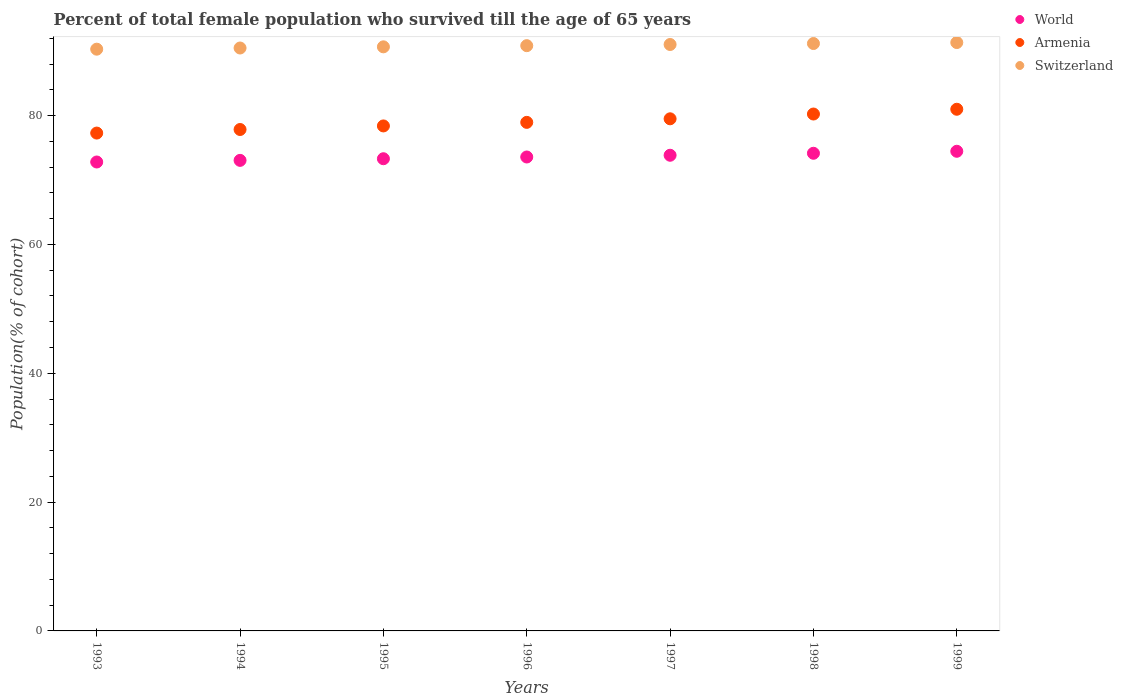How many different coloured dotlines are there?
Offer a very short reply. 3. What is the percentage of total female population who survived till the age of 65 years in World in 1997?
Ensure brevity in your answer.  73.84. Across all years, what is the maximum percentage of total female population who survived till the age of 65 years in Armenia?
Provide a short and direct response. 80.99. Across all years, what is the minimum percentage of total female population who survived till the age of 65 years in World?
Offer a very short reply. 72.8. In which year was the percentage of total female population who survived till the age of 65 years in Switzerland maximum?
Provide a succinct answer. 1999. What is the total percentage of total female population who survived till the age of 65 years in World in the graph?
Keep it short and to the point. 515.19. What is the difference between the percentage of total female population who survived till the age of 65 years in Switzerland in 1993 and that in 1996?
Keep it short and to the point. -0.54. What is the difference between the percentage of total female population who survived till the age of 65 years in Switzerland in 1997 and the percentage of total female population who survived till the age of 65 years in Armenia in 1996?
Provide a succinct answer. 12.09. What is the average percentage of total female population who survived till the age of 65 years in Armenia per year?
Give a very brief answer. 79.03. In the year 1994, what is the difference between the percentage of total female population who survived till the age of 65 years in Armenia and percentage of total female population who survived till the age of 65 years in World?
Your answer should be very brief. 4.79. What is the ratio of the percentage of total female population who survived till the age of 65 years in World in 1993 to that in 1994?
Provide a succinct answer. 1. Is the difference between the percentage of total female population who survived till the age of 65 years in Armenia in 1998 and 1999 greater than the difference between the percentage of total female population who survived till the age of 65 years in World in 1998 and 1999?
Offer a terse response. No. What is the difference between the highest and the second highest percentage of total female population who survived till the age of 65 years in World?
Your answer should be very brief. 0.31. What is the difference between the highest and the lowest percentage of total female population who survived till the age of 65 years in Armenia?
Your answer should be very brief. 3.7. In how many years, is the percentage of total female population who survived till the age of 65 years in Switzerland greater than the average percentage of total female population who survived till the age of 65 years in Switzerland taken over all years?
Provide a succinct answer. 4. Is it the case that in every year, the sum of the percentage of total female population who survived till the age of 65 years in World and percentage of total female population who survived till the age of 65 years in Armenia  is greater than the percentage of total female population who survived till the age of 65 years in Switzerland?
Make the answer very short. Yes. Is the percentage of total female population who survived till the age of 65 years in Switzerland strictly less than the percentage of total female population who survived till the age of 65 years in Armenia over the years?
Offer a very short reply. No. Does the graph contain any zero values?
Your response must be concise. No. Does the graph contain grids?
Make the answer very short. No. How are the legend labels stacked?
Provide a succinct answer. Vertical. What is the title of the graph?
Offer a very short reply. Percent of total female population who survived till the age of 65 years. What is the label or title of the Y-axis?
Offer a terse response. Population(% of cohort). What is the Population(% of cohort) of World in 1993?
Offer a terse response. 72.8. What is the Population(% of cohort) in Armenia in 1993?
Provide a succinct answer. 77.29. What is the Population(% of cohort) in Switzerland in 1993?
Provide a short and direct response. 90.31. What is the Population(% of cohort) in World in 1994?
Give a very brief answer. 73.05. What is the Population(% of cohort) in Armenia in 1994?
Provide a succinct answer. 77.84. What is the Population(% of cohort) in Switzerland in 1994?
Your answer should be compact. 90.49. What is the Population(% of cohort) in World in 1995?
Offer a terse response. 73.3. What is the Population(% of cohort) in Armenia in 1995?
Provide a succinct answer. 78.4. What is the Population(% of cohort) in Switzerland in 1995?
Offer a very short reply. 90.68. What is the Population(% of cohort) in World in 1996?
Give a very brief answer. 73.58. What is the Population(% of cohort) in Armenia in 1996?
Make the answer very short. 78.95. What is the Population(% of cohort) of Switzerland in 1996?
Ensure brevity in your answer.  90.86. What is the Population(% of cohort) of World in 1997?
Offer a terse response. 73.84. What is the Population(% of cohort) of Armenia in 1997?
Provide a succinct answer. 79.5. What is the Population(% of cohort) in Switzerland in 1997?
Your answer should be compact. 91.04. What is the Population(% of cohort) in World in 1998?
Give a very brief answer. 74.15. What is the Population(% of cohort) of Armenia in 1998?
Provide a succinct answer. 80.25. What is the Population(% of cohort) of Switzerland in 1998?
Ensure brevity in your answer.  91.19. What is the Population(% of cohort) in World in 1999?
Ensure brevity in your answer.  74.46. What is the Population(% of cohort) in Armenia in 1999?
Provide a succinct answer. 80.99. What is the Population(% of cohort) in Switzerland in 1999?
Keep it short and to the point. 91.34. Across all years, what is the maximum Population(% of cohort) in World?
Provide a short and direct response. 74.46. Across all years, what is the maximum Population(% of cohort) in Armenia?
Provide a succinct answer. 80.99. Across all years, what is the maximum Population(% of cohort) of Switzerland?
Your response must be concise. 91.34. Across all years, what is the minimum Population(% of cohort) of World?
Ensure brevity in your answer.  72.8. Across all years, what is the minimum Population(% of cohort) in Armenia?
Offer a terse response. 77.29. Across all years, what is the minimum Population(% of cohort) in Switzerland?
Ensure brevity in your answer.  90.31. What is the total Population(% of cohort) of World in the graph?
Your answer should be compact. 515.19. What is the total Population(% of cohort) in Armenia in the graph?
Offer a terse response. 553.21. What is the total Population(% of cohort) of Switzerland in the graph?
Give a very brief answer. 635.91. What is the difference between the Population(% of cohort) in World in 1993 and that in 1994?
Your response must be concise. -0.25. What is the difference between the Population(% of cohort) of Armenia in 1993 and that in 1994?
Your answer should be compact. -0.55. What is the difference between the Population(% of cohort) in Switzerland in 1993 and that in 1994?
Your answer should be very brief. -0.18. What is the difference between the Population(% of cohort) of World in 1993 and that in 1995?
Keep it short and to the point. -0.51. What is the difference between the Population(% of cohort) of Armenia in 1993 and that in 1995?
Provide a succinct answer. -1.11. What is the difference between the Population(% of cohort) of Switzerland in 1993 and that in 1995?
Give a very brief answer. -0.36. What is the difference between the Population(% of cohort) of World in 1993 and that in 1996?
Your response must be concise. -0.78. What is the difference between the Population(% of cohort) in Armenia in 1993 and that in 1996?
Provide a short and direct response. -1.66. What is the difference between the Population(% of cohort) in Switzerland in 1993 and that in 1996?
Provide a succinct answer. -0.54. What is the difference between the Population(% of cohort) in World in 1993 and that in 1997?
Your response must be concise. -1.05. What is the difference between the Population(% of cohort) in Armenia in 1993 and that in 1997?
Offer a very short reply. -2.22. What is the difference between the Population(% of cohort) of Switzerland in 1993 and that in 1997?
Make the answer very short. -0.73. What is the difference between the Population(% of cohort) of World in 1993 and that in 1998?
Ensure brevity in your answer.  -1.35. What is the difference between the Population(% of cohort) of Armenia in 1993 and that in 1998?
Offer a very short reply. -2.96. What is the difference between the Population(% of cohort) in Switzerland in 1993 and that in 1998?
Your answer should be compact. -0.88. What is the difference between the Population(% of cohort) in World in 1993 and that in 1999?
Provide a short and direct response. -1.66. What is the difference between the Population(% of cohort) in Armenia in 1993 and that in 1999?
Provide a short and direct response. -3.7. What is the difference between the Population(% of cohort) of Switzerland in 1993 and that in 1999?
Give a very brief answer. -1.03. What is the difference between the Population(% of cohort) in World in 1994 and that in 1995?
Provide a short and direct response. -0.25. What is the difference between the Population(% of cohort) in Armenia in 1994 and that in 1995?
Your answer should be very brief. -0.55. What is the difference between the Population(% of cohort) of Switzerland in 1994 and that in 1995?
Provide a succinct answer. -0.18. What is the difference between the Population(% of cohort) of World in 1994 and that in 1996?
Give a very brief answer. -0.53. What is the difference between the Population(% of cohort) of Armenia in 1994 and that in 1996?
Make the answer very short. -1.11. What is the difference between the Population(% of cohort) of Switzerland in 1994 and that in 1996?
Your response must be concise. -0.36. What is the difference between the Population(% of cohort) of World in 1994 and that in 1997?
Keep it short and to the point. -0.79. What is the difference between the Population(% of cohort) of Armenia in 1994 and that in 1997?
Give a very brief answer. -1.66. What is the difference between the Population(% of cohort) of Switzerland in 1994 and that in 1997?
Provide a short and direct response. -0.54. What is the difference between the Population(% of cohort) of World in 1994 and that in 1998?
Your answer should be compact. -1.1. What is the difference between the Population(% of cohort) in Armenia in 1994 and that in 1998?
Your answer should be compact. -2.4. What is the difference between the Population(% of cohort) of Switzerland in 1994 and that in 1998?
Your answer should be very brief. -0.7. What is the difference between the Population(% of cohort) of World in 1994 and that in 1999?
Ensure brevity in your answer.  -1.41. What is the difference between the Population(% of cohort) of Armenia in 1994 and that in 1999?
Keep it short and to the point. -3.14. What is the difference between the Population(% of cohort) of Switzerland in 1994 and that in 1999?
Your answer should be very brief. -0.85. What is the difference between the Population(% of cohort) of World in 1995 and that in 1996?
Ensure brevity in your answer.  -0.27. What is the difference between the Population(% of cohort) of Armenia in 1995 and that in 1996?
Give a very brief answer. -0.55. What is the difference between the Population(% of cohort) in Switzerland in 1995 and that in 1996?
Your response must be concise. -0.18. What is the difference between the Population(% of cohort) of World in 1995 and that in 1997?
Your response must be concise. -0.54. What is the difference between the Population(% of cohort) of Armenia in 1995 and that in 1997?
Your answer should be compact. -1.11. What is the difference between the Population(% of cohort) in Switzerland in 1995 and that in 1997?
Your answer should be compact. -0.36. What is the difference between the Population(% of cohort) in World in 1995 and that in 1998?
Your answer should be compact. -0.85. What is the difference between the Population(% of cohort) of Armenia in 1995 and that in 1998?
Provide a short and direct response. -1.85. What is the difference between the Population(% of cohort) in Switzerland in 1995 and that in 1998?
Make the answer very short. -0.51. What is the difference between the Population(% of cohort) of World in 1995 and that in 1999?
Keep it short and to the point. -1.16. What is the difference between the Population(% of cohort) in Armenia in 1995 and that in 1999?
Provide a succinct answer. -2.59. What is the difference between the Population(% of cohort) in Switzerland in 1995 and that in 1999?
Give a very brief answer. -0.67. What is the difference between the Population(% of cohort) in World in 1996 and that in 1997?
Give a very brief answer. -0.27. What is the difference between the Population(% of cohort) of Armenia in 1996 and that in 1997?
Provide a succinct answer. -0.55. What is the difference between the Population(% of cohort) in Switzerland in 1996 and that in 1997?
Offer a terse response. -0.18. What is the difference between the Population(% of cohort) in World in 1996 and that in 1998?
Provide a short and direct response. -0.58. What is the difference between the Population(% of cohort) of Armenia in 1996 and that in 1998?
Offer a terse response. -1.29. What is the difference between the Population(% of cohort) of Switzerland in 1996 and that in 1998?
Ensure brevity in your answer.  -0.33. What is the difference between the Population(% of cohort) in World in 1996 and that in 1999?
Ensure brevity in your answer.  -0.89. What is the difference between the Population(% of cohort) in Armenia in 1996 and that in 1999?
Your answer should be compact. -2.04. What is the difference between the Population(% of cohort) in Switzerland in 1996 and that in 1999?
Your answer should be compact. -0.48. What is the difference between the Population(% of cohort) in World in 1997 and that in 1998?
Offer a terse response. -0.31. What is the difference between the Population(% of cohort) in Armenia in 1997 and that in 1998?
Your answer should be compact. -0.74. What is the difference between the Population(% of cohort) of Switzerland in 1997 and that in 1998?
Make the answer very short. -0.15. What is the difference between the Population(% of cohort) of World in 1997 and that in 1999?
Give a very brief answer. -0.62. What is the difference between the Population(% of cohort) in Armenia in 1997 and that in 1999?
Make the answer very short. -1.48. What is the difference between the Population(% of cohort) in Switzerland in 1997 and that in 1999?
Your answer should be compact. -0.3. What is the difference between the Population(% of cohort) in World in 1998 and that in 1999?
Ensure brevity in your answer.  -0.31. What is the difference between the Population(% of cohort) in Armenia in 1998 and that in 1999?
Ensure brevity in your answer.  -0.74. What is the difference between the Population(% of cohort) of Switzerland in 1998 and that in 1999?
Provide a short and direct response. -0.15. What is the difference between the Population(% of cohort) of World in 1993 and the Population(% of cohort) of Armenia in 1994?
Provide a succinct answer. -5.04. What is the difference between the Population(% of cohort) of World in 1993 and the Population(% of cohort) of Switzerland in 1994?
Your answer should be compact. -17.7. What is the difference between the Population(% of cohort) in Armenia in 1993 and the Population(% of cohort) in Switzerland in 1994?
Provide a short and direct response. -13.21. What is the difference between the Population(% of cohort) in World in 1993 and the Population(% of cohort) in Armenia in 1995?
Offer a very short reply. -5.6. What is the difference between the Population(% of cohort) of World in 1993 and the Population(% of cohort) of Switzerland in 1995?
Your answer should be very brief. -17.88. What is the difference between the Population(% of cohort) of Armenia in 1993 and the Population(% of cohort) of Switzerland in 1995?
Keep it short and to the point. -13.39. What is the difference between the Population(% of cohort) of World in 1993 and the Population(% of cohort) of Armenia in 1996?
Make the answer very short. -6.15. What is the difference between the Population(% of cohort) of World in 1993 and the Population(% of cohort) of Switzerland in 1996?
Ensure brevity in your answer.  -18.06. What is the difference between the Population(% of cohort) in Armenia in 1993 and the Population(% of cohort) in Switzerland in 1996?
Offer a terse response. -13.57. What is the difference between the Population(% of cohort) of World in 1993 and the Population(% of cohort) of Armenia in 1997?
Offer a terse response. -6.71. What is the difference between the Population(% of cohort) in World in 1993 and the Population(% of cohort) in Switzerland in 1997?
Your response must be concise. -18.24. What is the difference between the Population(% of cohort) of Armenia in 1993 and the Population(% of cohort) of Switzerland in 1997?
Keep it short and to the point. -13.75. What is the difference between the Population(% of cohort) of World in 1993 and the Population(% of cohort) of Armenia in 1998?
Keep it short and to the point. -7.45. What is the difference between the Population(% of cohort) in World in 1993 and the Population(% of cohort) in Switzerland in 1998?
Make the answer very short. -18.39. What is the difference between the Population(% of cohort) in Armenia in 1993 and the Population(% of cohort) in Switzerland in 1998?
Offer a very short reply. -13.9. What is the difference between the Population(% of cohort) in World in 1993 and the Population(% of cohort) in Armenia in 1999?
Offer a terse response. -8.19. What is the difference between the Population(% of cohort) of World in 1993 and the Population(% of cohort) of Switzerland in 1999?
Keep it short and to the point. -18.54. What is the difference between the Population(% of cohort) in Armenia in 1993 and the Population(% of cohort) in Switzerland in 1999?
Offer a terse response. -14.05. What is the difference between the Population(% of cohort) in World in 1994 and the Population(% of cohort) in Armenia in 1995?
Your answer should be compact. -5.35. What is the difference between the Population(% of cohort) of World in 1994 and the Population(% of cohort) of Switzerland in 1995?
Ensure brevity in your answer.  -17.63. What is the difference between the Population(% of cohort) in Armenia in 1994 and the Population(% of cohort) in Switzerland in 1995?
Your response must be concise. -12.83. What is the difference between the Population(% of cohort) in World in 1994 and the Population(% of cohort) in Armenia in 1996?
Your answer should be compact. -5.9. What is the difference between the Population(% of cohort) in World in 1994 and the Population(% of cohort) in Switzerland in 1996?
Keep it short and to the point. -17.81. What is the difference between the Population(% of cohort) in Armenia in 1994 and the Population(% of cohort) in Switzerland in 1996?
Make the answer very short. -13.01. What is the difference between the Population(% of cohort) in World in 1994 and the Population(% of cohort) in Armenia in 1997?
Provide a short and direct response. -6.45. What is the difference between the Population(% of cohort) in World in 1994 and the Population(% of cohort) in Switzerland in 1997?
Provide a succinct answer. -17.99. What is the difference between the Population(% of cohort) of Armenia in 1994 and the Population(% of cohort) of Switzerland in 1997?
Offer a very short reply. -13.2. What is the difference between the Population(% of cohort) of World in 1994 and the Population(% of cohort) of Armenia in 1998?
Make the answer very short. -7.19. What is the difference between the Population(% of cohort) of World in 1994 and the Population(% of cohort) of Switzerland in 1998?
Make the answer very short. -18.14. What is the difference between the Population(% of cohort) in Armenia in 1994 and the Population(% of cohort) in Switzerland in 1998?
Your answer should be compact. -13.35. What is the difference between the Population(% of cohort) in World in 1994 and the Population(% of cohort) in Armenia in 1999?
Give a very brief answer. -7.94. What is the difference between the Population(% of cohort) in World in 1994 and the Population(% of cohort) in Switzerland in 1999?
Your response must be concise. -18.29. What is the difference between the Population(% of cohort) of Armenia in 1994 and the Population(% of cohort) of Switzerland in 1999?
Provide a succinct answer. -13.5. What is the difference between the Population(% of cohort) of World in 1995 and the Population(% of cohort) of Armenia in 1996?
Provide a succinct answer. -5.65. What is the difference between the Population(% of cohort) of World in 1995 and the Population(% of cohort) of Switzerland in 1996?
Ensure brevity in your answer.  -17.55. What is the difference between the Population(% of cohort) in Armenia in 1995 and the Population(% of cohort) in Switzerland in 1996?
Make the answer very short. -12.46. What is the difference between the Population(% of cohort) in World in 1995 and the Population(% of cohort) in Switzerland in 1997?
Keep it short and to the point. -17.73. What is the difference between the Population(% of cohort) of Armenia in 1995 and the Population(% of cohort) of Switzerland in 1997?
Offer a terse response. -12.64. What is the difference between the Population(% of cohort) in World in 1995 and the Population(% of cohort) in Armenia in 1998?
Offer a terse response. -6.94. What is the difference between the Population(% of cohort) in World in 1995 and the Population(% of cohort) in Switzerland in 1998?
Your answer should be very brief. -17.89. What is the difference between the Population(% of cohort) of Armenia in 1995 and the Population(% of cohort) of Switzerland in 1998?
Your answer should be compact. -12.79. What is the difference between the Population(% of cohort) of World in 1995 and the Population(% of cohort) of Armenia in 1999?
Provide a succinct answer. -7.68. What is the difference between the Population(% of cohort) of World in 1995 and the Population(% of cohort) of Switzerland in 1999?
Your response must be concise. -18.04. What is the difference between the Population(% of cohort) in Armenia in 1995 and the Population(% of cohort) in Switzerland in 1999?
Keep it short and to the point. -12.95. What is the difference between the Population(% of cohort) in World in 1996 and the Population(% of cohort) in Armenia in 1997?
Provide a succinct answer. -5.93. What is the difference between the Population(% of cohort) in World in 1996 and the Population(% of cohort) in Switzerland in 1997?
Your answer should be compact. -17.46. What is the difference between the Population(% of cohort) of Armenia in 1996 and the Population(% of cohort) of Switzerland in 1997?
Offer a terse response. -12.09. What is the difference between the Population(% of cohort) in World in 1996 and the Population(% of cohort) in Armenia in 1998?
Ensure brevity in your answer.  -6.67. What is the difference between the Population(% of cohort) in World in 1996 and the Population(% of cohort) in Switzerland in 1998?
Offer a very short reply. -17.61. What is the difference between the Population(% of cohort) in Armenia in 1996 and the Population(% of cohort) in Switzerland in 1998?
Your answer should be very brief. -12.24. What is the difference between the Population(% of cohort) of World in 1996 and the Population(% of cohort) of Armenia in 1999?
Offer a terse response. -7.41. What is the difference between the Population(% of cohort) in World in 1996 and the Population(% of cohort) in Switzerland in 1999?
Offer a terse response. -17.77. What is the difference between the Population(% of cohort) in Armenia in 1996 and the Population(% of cohort) in Switzerland in 1999?
Your response must be concise. -12.39. What is the difference between the Population(% of cohort) of World in 1997 and the Population(% of cohort) of Armenia in 1998?
Your answer should be compact. -6.4. What is the difference between the Population(% of cohort) of World in 1997 and the Population(% of cohort) of Switzerland in 1998?
Provide a succinct answer. -17.35. What is the difference between the Population(% of cohort) of Armenia in 1997 and the Population(% of cohort) of Switzerland in 1998?
Keep it short and to the point. -11.69. What is the difference between the Population(% of cohort) in World in 1997 and the Population(% of cohort) in Armenia in 1999?
Ensure brevity in your answer.  -7.14. What is the difference between the Population(% of cohort) in World in 1997 and the Population(% of cohort) in Switzerland in 1999?
Ensure brevity in your answer.  -17.5. What is the difference between the Population(% of cohort) in Armenia in 1997 and the Population(% of cohort) in Switzerland in 1999?
Give a very brief answer. -11.84. What is the difference between the Population(% of cohort) in World in 1998 and the Population(% of cohort) in Armenia in 1999?
Give a very brief answer. -6.83. What is the difference between the Population(% of cohort) of World in 1998 and the Population(% of cohort) of Switzerland in 1999?
Your answer should be very brief. -17.19. What is the difference between the Population(% of cohort) of Armenia in 1998 and the Population(% of cohort) of Switzerland in 1999?
Keep it short and to the point. -11.1. What is the average Population(% of cohort) of World per year?
Offer a terse response. 73.6. What is the average Population(% of cohort) in Armenia per year?
Offer a very short reply. 79.03. What is the average Population(% of cohort) of Switzerland per year?
Your answer should be compact. 90.84. In the year 1993, what is the difference between the Population(% of cohort) of World and Population(% of cohort) of Armenia?
Make the answer very short. -4.49. In the year 1993, what is the difference between the Population(% of cohort) of World and Population(% of cohort) of Switzerland?
Give a very brief answer. -17.51. In the year 1993, what is the difference between the Population(% of cohort) of Armenia and Population(% of cohort) of Switzerland?
Keep it short and to the point. -13.02. In the year 1994, what is the difference between the Population(% of cohort) in World and Population(% of cohort) in Armenia?
Your response must be concise. -4.79. In the year 1994, what is the difference between the Population(% of cohort) in World and Population(% of cohort) in Switzerland?
Provide a short and direct response. -17.44. In the year 1994, what is the difference between the Population(% of cohort) in Armenia and Population(% of cohort) in Switzerland?
Keep it short and to the point. -12.65. In the year 1995, what is the difference between the Population(% of cohort) of World and Population(% of cohort) of Armenia?
Your answer should be very brief. -5.09. In the year 1995, what is the difference between the Population(% of cohort) of World and Population(% of cohort) of Switzerland?
Provide a succinct answer. -17.37. In the year 1995, what is the difference between the Population(% of cohort) of Armenia and Population(% of cohort) of Switzerland?
Provide a short and direct response. -12.28. In the year 1996, what is the difference between the Population(% of cohort) of World and Population(% of cohort) of Armenia?
Keep it short and to the point. -5.37. In the year 1996, what is the difference between the Population(% of cohort) in World and Population(% of cohort) in Switzerland?
Keep it short and to the point. -17.28. In the year 1996, what is the difference between the Population(% of cohort) in Armenia and Population(% of cohort) in Switzerland?
Keep it short and to the point. -11.91. In the year 1997, what is the difference between the Population(% of cohort) of World and Population(% of cohort) of Armenia?
Offer a very short reply. -5.66. In the year 1997, what is the difference between the Population(% of cohort) of World and Population(% of cohort) of Switzerland?
Your response must be concise. -17.19. In the year 1997, what is the difference between the Population(% of cohort) in Armenia and Population(% of cohort) in Switzerland?
Ensure brevity in your answer.  -11.53. In the year 1998, what is the difference between the Population(% of cohort) in World and Population(% of cohort) in Armenia?
Provide a succinct answer. -6.09. In the year 1998, what is the difference between the Population(% of cohort) in World and Population(% of cohort) in Switzerland?
Your response must be concise. -17.04. In the year 1998, what is the difference between the Population(% of cohort) in Armenia and Population(% of cohort) in Switzerland?
Make the answer very short. -10.95. In the year 1999, what is the difference between the Population(% of cohort) of World and Population(% of cohort) of Armenia?
Provide a short and direct response. -6.52. In the year 1999, what is the difference between the Population(% of cohort) of World and Population(% of cohort) of Switzerland?
Your response must be concise. -16.88. In the year 1999, what is the difference between the Population(% of cohort) in Armenia and Population(% of cohort) in Switzerland?
Your answer should be compact. -10.36. What is the ratio of the Population(% of cohort) of World in 1993 to that in 1994?
Offer a very short reply. 1. What is the ratio of the Population(% of cohort) of Switzerland in 1993 to that in 1994?
Your answer should be compact. 1. What is the ratio of the Population(% of cohort) of World in 1993 to that in 1995?
Your answer should be compact. 0.99. What is the ratio of the Population(% of cohort) in Armenia in 1993 to that in 1995?
Offer a terse response. 0.99. What is the ratio of the Population(% of cohort) of World in 1993 to that in 1996?
Offer a very short reply. 0.99. What is the ratio of the Population(% of cohort) of Armenia in 1993 to that in 1996?
Make the answer very short. 0.98. What is the ratio of the Population(% of cohort) of World in 1993 to that in 1997?
Offer a terse response. 0.99. What is the ratio of the Population(% of cohort) of Armenia in 1993 to that in 1997?
Provide a succinct answer. 0.97. What is the ratio of the Population(% of cohort) in Switzerland in 1993 to that in 1997?
Offer a very short reply. 0.99. What is the ratio of the Population(% of cohort) in World in 1993 to that in 1998?
Your answer should be very brief. 0.98. What is the ratio of the Population(% of cohort) of Armenia in 1993 to that in 1998?
Provide a succinct answer. 0.96. What is the ratio of the Population(% of cohort) in Switzerland in 1993 to that in 1998?
Your response must be concise. 0.99. What is the ratio of the Population(% of cohort) of World in 1993 to that in 1999?
Give a very brief answer. 0.98. What is the ratio of the Population(% of cohort) in Armenia in 1993 to that in 1999?
Offer a terse response. 0.95. What is the ratio of the Population(% of cohort) in Switzerland in 1993 to that in 1999?
Your response must be concise. 0.99. What is the ratio of the Population(% of cohort) of Armenia in 1994 to that in 1995?
Offer a terse response. 0.99. What is the ratio of the Population(% of cohort) of Switzerland in 1994 to that in 1995?
Ensure brevity in your answer.  1. What is the ratio of the Population(% of cohort) in Armenia in 1994 to that in 1996?
Your answer should be very brief. 0.99. What is the ratio of the Population(% of cohort) of Switzerland in 1994 to that in 1996?
Your answer should be very brief. 1. What is the ratio of the Population(% of cohort) of World in 1994 to that in 1997?
Your answer should be very brief. 0.99. What is the ratio of the Population(% of cohort) of Armenia in 1994 to that in 1997?
Your answer should be very brief. 0.98. What is the ratio of the Population(% of cohort) in Switzerland in 1994 to that in 1997?
Make the answer very short. 0.99. What is the ratio of the Population(% of cohort) in World in 1994 to that in 1998?
Provide a short and direct response. 0.99. What is the ratio of the Population(% of cohort) of Armenia in 1994 to that in 1998?
Make the answer very short. 0.97. What is the ratio of the Population(% of cohort) in Armenia in 1994 to that in 1999?
Provide a succinct answer. 0.96. What is the ratio of the Population(% of cohort) of Switzerland in 1994 to that in 1999?
Provide a succinct answer. 0.99. What is the ratio of the Population(% of cohort) in Armenia in 1995 to that in 1997?
Provide a short and direct response. 0.99. What is the ratio of the Population(% of cohort) of Switzerland in 1995 to that in 1998?
Offer a very short reply. 0.99. What is the ratio of the Population(% of cohort) of World in 1995 to that in 1999?
Offer a very short reply. 0.98. What is the ratio of the Population(% of cohort) of Armenia in 1995 to that in 1999?
Ensure brevity in your answer.  0.97. What is the ratio of the Population(% of cohort) in Switzerland in 1996 to that in 1997?
Your answer should be compact. 1. What is the ratio of the Population(% of cohort) of World in 1996 to that in 1998?
Your answer should be compact. 0.99. What is the ratio of the Population(% of cohort) of Armenia in 1996 to that in 1998?
Keep it short and to the point. 0.98. What is the ratio of the Population(% of cohort) in World in 1996 to that in 1999?
Provide a succinct answer. 0.99. What is the ratio of the Population(% of cohort) in Armenia in 1996 to that in 1999?
Your answer should be compact. 0.97. What is the ratio of the Population(% of cohort) of Armenia in 1997 to that in 1998?
Provide a succinct answer. 0.99. What is the ratio of the Population(% of cohort) of Armenia in 1997 to that in 1999?
Ensure brevity in your answer.  0.98. What is the ratio of the Population(% of cohort) of Armenia in 1998 to that in 1999?
Keep it short and to the point. 0.99. What is the ratio of the Population(% of cohort) in Switzerland in 1998 to that in 1999?
Offer a terse response. 1. What is the difference between the highest and the second highest Population(% of cohort) of World?
Provide a succinct answer. 0.31. What is the difference between the highest and the second highest Population(% of cohort) in Armenia?
Your answer should be very brief. 0.74. What is the difference between the highest and the second highest Population(% of cohort) of Switzerland?
Provide a succinct answer. 0.15. What is the difference between the highest and the lowest Population(% of cohort) of World?
Your answer should be compact. 1.66. What is the difference between the highest and the lowest Population(% of cohort) in Armenia?
Your answer should be compact. 3.7. What is the difference between the highest and the lowest Population(% of cohort) in Switzerland?
Your answer should be very brief. 1.03. 